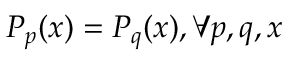Convert formula to latex. <formula><loc_0><loc_0><loc_500><loc_500>P _ { p } ( x ) = P _ { q } ( x ) , \forall p , q , x</formula> 